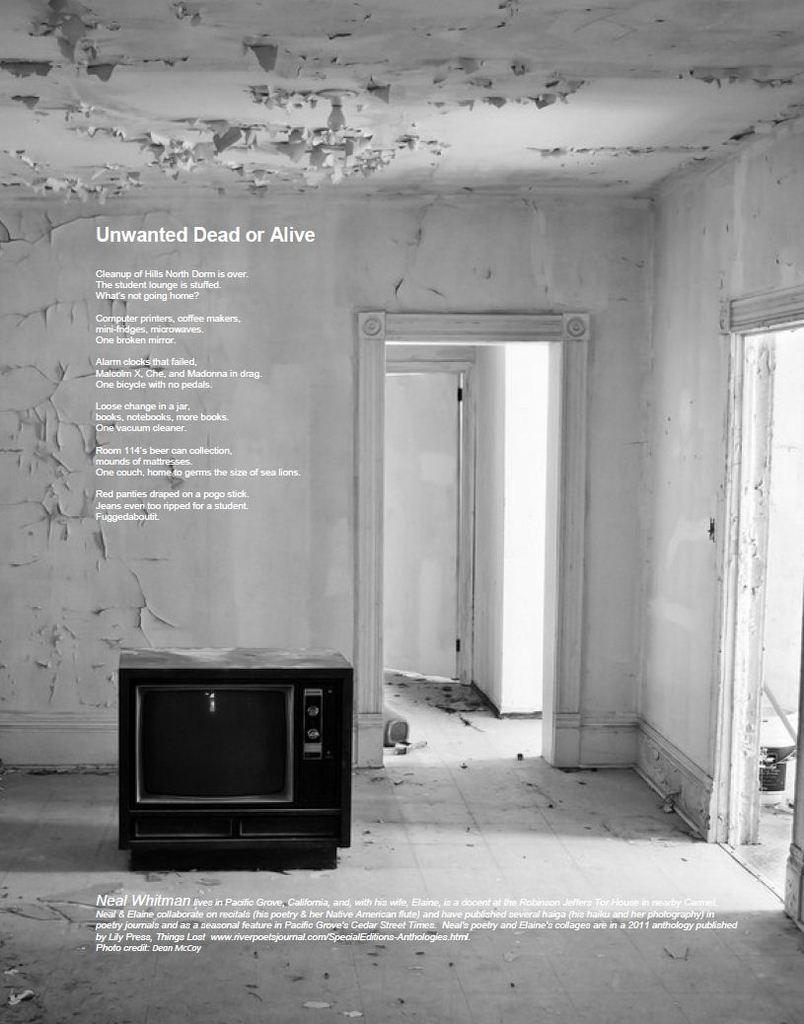Provide a one-sentence caption for the provided image. a black and white ad with an old console tv for unwanted dead or alive. 